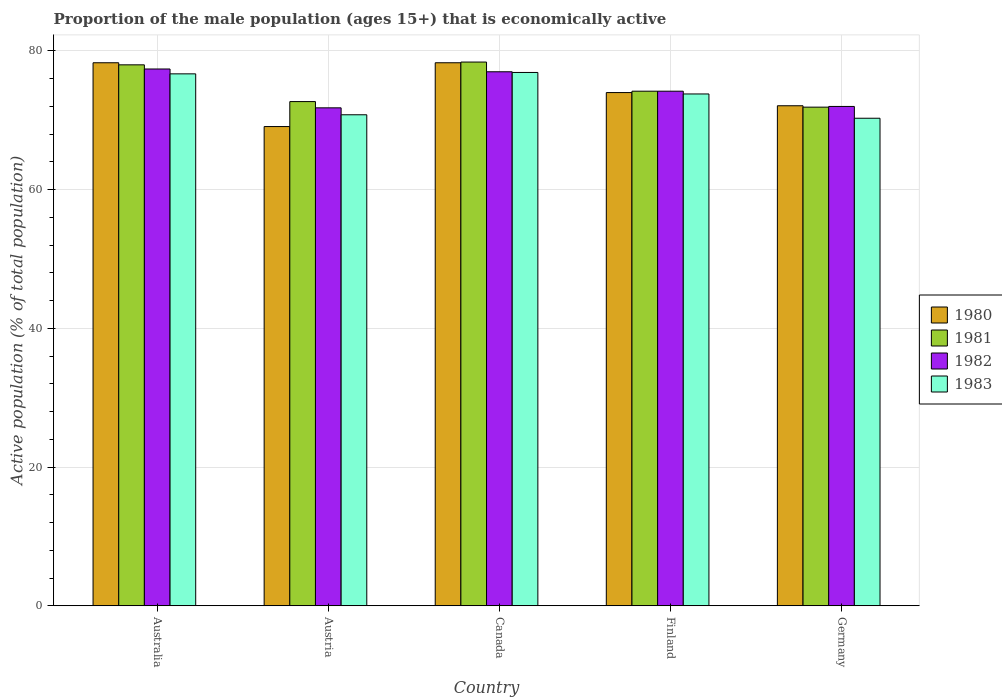Are the number of bars per tick equal to the number of legend labels?
Your response must be concise. Yes. Are the number of bars on each tick of the X-axis equal?
Give a very brief answer. Yes. How many bars are there on the 4th tick from the left?
Offer a very short reply. 4. How many bars are there on the 2nd tick from the right?
Make the answer very short. 4. What is the label of the 1st group of bars from the left?
Provide a succinct answer. Australia. In how many cases, is the number of bars for a given country not equal to the number of legend labels?
Offer a very short reply. 0. What is the proportion of the male population that is economically active in 1980 in Austria?
Ensure brevity in your answer.  69.1. Across all countries, what is the maximum proportion of the male population that is economically active in 1982?
Give a very brief answer. 77.4. Across all countries, what is the minimum proportion of the male population that is economically active in 1982?
Offer a very short reply. 71.8. In which country was the proportion of the male population that is economically active in 1981 minimum?
Give a very brief answer. Germany. What is the total proportion of the male population that is economically active in 1983 in the graph?
Give a very brief answer. 368.5. What is the average proportion of the male population that is economically active in 1983 per country?
Offer a very short reply. 73.7. What is the difference between the proportion of the male population that is economically active of/in 1983 and proportion of the male population that is economically active of/in 1982 in Finland?
Give a very brief answer. -0.4. In how many countries, is the proportion of the male population that is economically active in 1981 greater than 60 %?
Your answer should be very brief. 5. What is the ratio of the proportion of the male population that is economically active in 1983 in Canada to that in Finland?
Your answer should be very brief. 1.04. Is the proportion of the male population that is economically active in 1983 in Canada less than that in Germany?
Keep it short and to the point. No. Is the difference between the proportion of the male population that is economically active in 1983 in Austria and Germany greater than the difference between the proportion of the male population that is economically active in 1982 in Austria and Germany?
Your response must be concise. Yes. What is the difference between the highest and the second highest proportion of the male population that is economically active in 1980?
Provide a short and direct response. -4.3. What is the difference between the highest and the lowest proportion of the male population that is economically active in 1983?
Your answer should be very brief. 6.6. Is it the case that in every country, the sum of the proportion of the male population that is economically active in 1981 and proportion of the male population that is economically active in 1982 is greater than the sum of proportion of the male population that is economically active in 1980 and proportion of the male population that is economically active in 1983?
Make the answer very short. Yes. Are all the bars in the graph horizontal?
Provide a succinct answer. No. How many countries are there in the graph?
Your answer should be very brief. 5. What is the difference between two consecutive major ticks on the Y-axis?
Offer a very short reply. 20. Does the graph contain grids?
Your answer should be very brief. Yes. Where does the legend appear in the graph?
Your answer should be very brief. Center right. How many legend labels are there?
Ensure brevity in your answer.  4. How are the legend labels stacked?
Offer a very short reply. Vertical. What is the title of the graph?
Make the answer very short. Proportion of the male population (ages 15+) that is economically active. Does "1967" appear as one of the legend labels in the graph?
Provide a short and direct response. No. What is the label or title of the Y-axis?
Make the answer very short. Active population (% of total population). What is the Active population (% of total population) of 1980 in Australia?
Provide a short and direct response. 78.3. What is the Active population (% of total population) of 1982 in Australia?
Provide a succinct answer. 77.4. What is the Active population (% of total population) of 1983 in Australia?
Give a very brief answer. 76.7. What is the Active population (% of total population) in 1980 in Austria?
Offer a terse response. 69.1. What is the Active population (% of total population) of 1981 in Austria?
Your answer should be compact. 72.7. What is the Active population (% of total population) in 1982 in Austria?
Provide a short and direct response. 71.8. What is the Active population (% of total population) of 1983 in Austria?
Offer a terse response. 70.8. What is the Active population (% of total population) in 1980 in Canada?
Keep it short and to the point. 78.3. What is the Active population (% of total population) of 1981 in Canada?
Make the answer very short. 78.4. What is the Active population (% of total population) of 1983 in Canada?
Provide a succinct answer. 76.9. What is the Active population (% of total population) in 1980 in Finland?
Your answer should be very brief. 74. What is the Active population (% of total population) in 1981 in Finland?
Provide a succinct answer. 74.2. What is the Active population (% of total population) of 1982 in Finland?
Offer a very short reply. 74.2. What is the Active population (% of total population) in 1983 in Finland?
Make the answer very short. 73.8. What is the Active population (% of total population) of 1980 in Germany?
Provide a succinct answer. 72.1. What is the Active population (% of total population) of 1981 in Germany?
Your response must be concise. 71.9. What is the Active population (% of total population) in 1983 in Germany?
Provide a short and direct response. 70.3. Across all countries, what is the maximum Active population (% of total population) in 1980?
Offer a terse response. 78.3. Across all countries, what is the maximum Active population (% of total population) of 1981?
Offer a very short reply. 78.4. Across all countries, what is the maximum Active population (% of total population) of 1982?
Keep it short and to the point. 77.4. Across all countries, what is the maximum Active population (% of total population) of 1983?
Your answer should be very brief. 76.9. Across all countries, what is the minimum Active population (% of total population) of 1980?
Provide a short and direct response. 69.1. Across all countries, what is the minimum Active population (% of total population) of 1981?
Provide a succinct answer. 71.9. Across all countries, what is the minimum Active population (% of total population) of 1982?
Ensure brevity in your answer.  71.8. Across all countries, what is the minimum Active population (% of total population) in 1983?
Give a very brief answer. 70.3. What is the total Active population (% of total population) in 1980 in the graph?
Keep it short and to the point. 371.8. What is the total Active population (% of total population) in 1981 in the graph?
Offer a terse response. 375.2. What is the total Active population (% of total population) in 1982 in the graph?
Ensure brevity in your answer.  372.4. What is the total Active population (% of total population) in 1983 in the graph?
Provide a succinct answer. 368.5. What is the difference between the Active population (% of total population) of 1980 in Australia and that in Austria?
Provide a succinct answer. 9.2. What is the difference between the Active population (% of total population) in 1981 in Australia and that in Austria?
Provide a succinct answer. 5.3. What is the difference between the Active population (% of total population) in 1982 in Australia and that in Austria?
Keep it short and to the point. 5.6. What is the difference between the Active population (% of total population) of 1983 in Australia and that in Austria?
Your response must be concise. 5.9. What is the difference between the Active population (% of total population) of 1980 in Australia and that in Canada?
Your answer should be compact. 0. What is the difference between the Active population (% of total population) of 1982 in Australia and that in Canada?
Provide a succinct answer. 0.4. What is the difference between the Active population (% of total population) of 1980 in Australia and that in Finland?
Your answer should be compact. 4.3. What is the difference between the Active population (% of total population) in 1980 in Australia and that in Germany?
Keep it short and to the point. 6.2. What is the difference between the Active population (% of total population) of 1981 in Australia and that in Germany?
Make the answer very short. 6.1. What is the difference between the Active population (% of total population) of 1981 in Austria and that in Canada?
Provide a succinct answer. -5.7. What is the difference between the Active population (% of total population) in 1982 in Austria and that in Canada?
Provide a short and direct response. -5.2. What is the difference between the Active population (% of total population) of 1983 in Austria and that in Canada?
Keep it short and to the point. -6.1. What is the difference between the Active population (% of total population) in 1980 in Austria and that in Finland?
Your answer should be compact. -4.9. What is the difference between the Active population (% of total population) in 1981 in Austria and that in Finland?
Ensure brevity in your answer.  -1.5. What is the difference between the Active population (% of total population) of 1982 in Canada and that in Finland?
Your response must be concise. 2.8. What is the difference between the Active population (% of total population) of 1983 in Canada and that in Finland?
Your response must be concise. 3.1. What is the difference between the Active population (% of total population) in 1980 in Canada and that in Germany?
Provide a short and direct response. 6.2. What is the difference between the Active population (% of total population) in 1980 in Finland and that in Germany?
Your answer should be very brief. 1.9. What is the difference between the Active population (% of total population) in 1983 in Finland and that in Germany?
Provide a short and direct response. 3.5. What is the difference between the Active population (% of total population) in 1980 in Australia and the Active population (% of total population) in 1983 in Austria?
Your answer should be very brief. 7.5. What is the difference between the Active population (% of total population) of 1981 in Australia and the Active population (% of total population) of 1982 in Austria?
Offer a very short reply. 6.2. What is the difference between the Active population (% of total population) of 1981 in Australia and the Active population (% of total population) of 1983 in Austria?
Your response must be concise. 7.2. What is the difference between the Active population (% of total population) in 1982 in Australia and the Active population (% of total population) in 1983 in Austria?
Ensure brevity in your answer.  6.6. What is the difference between the Active population (% of total population) of 1980 in Australia and the Active population (% of total population) of 1982 in Canada?
Offer a very short reply. 1.3. What is the difference between the Active population (% of total population) of 1980 in Australia and the Active population (% of total population) of 1983 in Canada?
Provide a short and direct response. 1.4. What is the difference between the Active population (% of total population) of 1982 in Australia and the Active population (% of total population) of 1983 in Finland?
Provide a succinct answer. 3.6. What is the difference between the Active population (% of total population) of 1980 in Australia and the Active population (% of total population) of 1981 in Germany?
Ensure brevity in your answer.  6.4. What is the difference between the Active population (% of total population) in 1980 in Australia and the Active population (% of total population) in 1983 in Germany?
Your answer should be very brief. 8. What is the difference between the Active population (% of total population) of 1980 in Austria and the Active population (% of total population) of 1981 in Canada?
Give a very brief answer. -9.3. What is the difference between the Active population (% of total population) in 1980 in Austria and the Active population (% of total population) in 1983 in Canada?
Your answer should be very brief. -7.8. What is the difference between the Active population (% of total population) of 1981 in Austria and the Active population (% of total population) of 1982 in Canada?
Keep it short and to the point. -4.3. What is the difference between the Active population (% of total population) of 1981 in Austria and the Active population (% of total population) of 1983 in Canada?
Your answer should be very brief. -4.2. What is the difference between the Active population (% of total population) of 1980 in Austria and the Active population (% of total population) of 1981 in Finland?
Provide a short and direct response. -5.1. What is the difference between the Active population (% of total population) in 1980 in Austria and the Active population (% of total population) in 1982 in Finland?
Offer a terse response. -5.1. What is the difference between the Active population (% of total population) in 1981 in Austria and the Active population (% of total population) in 1982 in Finland?
Your answer should be compact. -1.5. What is the difference between the Active population (% of total population) of 1981 in Austria and the Active population (% of total population) of 1983 in Finland?
Offer a terse response. -1.1. What is the difference between the Active population (% of total population) of 1982 in Austria and the Active population (% of total population) of 1983 in Finland?
Make the answer very short. -2. What is the difference between the Active population (% of total population) of 1981 in Austria and the Active population (% of total population) of 1982 in Germany?
Provide a short and direct response. 0.7. What is the difference between the Active population (% of total population) of 1981 in Austria and the Active population (% of total population) of 1983 in Germany?
Keep it short and to the point. 2.4. What is the difference between the Active population (% of total population) of 1982 in Austria and the Active population (% of total population) of 1983 in Germany?
Keep it short and to the point. 1.5. What is the difference between the Active population (% of total population) in 1980 in Canada and the Active population (% of total population) in 1983 in Finland?
Ensure brevity in your answer.  4.5. What is the difference between the Active population (% of total population) of 1981 in Canada and the Active population (% of total population) of 1982 in Finland?
Provide a succinct answer. 4.2. What is the difference between the Active population (% of total population) of 1980 in Canada and the Active population (% of total population) of 1982 in Germany?
Offer a very short reply. 6.3. What is the difference between the Active population (% of total population) in 1980 in Canada and the Active population (% of total population) in 1983 in Germany?
Offer a terse response. 8. What is the difference between the Active population (% of total population) in 1981 in Canada and the Active population (% of total population) in 1982 in Germany?
Your answer should be very brief. 6.4. What is the difference between the Active population (% of total population) of 1980 in Finland and the Active population (% of total population) of 1981 in Germany?
Offer a very short reply. 2.1. What is the difference between the Active population (% of total population) in 1980 in Finland and the Active population (% of total population) in 1983 in Germany?
Your answer should be very brief. 3.7. What is the average Active population (% of total population) in 1980 per country?
Keep it short and to the point. 74.36. What is the average Active population (% of total population) in 1981 per country?
Ensure brevity in your answer.  75.04. What is the average Active population (% of total population) of 1982 per country?
Ensure brevity in your answer.  74.48. What is the average Active population (% of total population) in 1983 per country?
Ensure brevity in your answer.  73.7. What is the difference between the Active population (% of total population) in 1980 and Active population (% of total population) in 1982 in Australia?
Provide a succinct answer. 0.9. What is the difference between the Active population (% of total population) of 1980 and Active population (% of total population) of 1983 in Australia?
Offer a terse response. 1.6. What is the difference between the Active population (% of total population) in 1981 and Active population (% of total population) in 1982 in Australia?
Ensure brevity in your answer.  0.6. What is the difference between the Active population (% of total population) of 1981 and Active population (% of total population) of 1983 in Australia?
Your answer should be very brief. 1.3. What is the difference between the Active population (% of total population) in 1982 and Active population (% of total population) in 1983 in Australia?
Make the answer very short. 0.7. What is the difference between the Active population (% of total population) in 1980 and Active population (% of total population) in 1982 in Austria?
Make the answer very short. -2.7. What is the difference between the Active population (% of total population) of 1980 and Active population (% of total population) of 1983 in Austria?
Provide a succinct answer. -1.7. What is the difference between the Active population (% of total population) of 1981 and Active population (% of total population) of 1982 in Austria?
Your answer should be very brief. 0.9. What is the difference between the Active population (% of total population) in 1982 and Active population (% of total population) in 1983 in Austria?
Your answer should be compact. 1. What is the difference between the Active population (% of total population) of 1980 and Active population (% of total population) of 1982 in Canada?
Keep it short and to the point. 1.3. What is the difference between the Active population (% of total population) in 1980 and Active population (% of total population) in 1983 in Canada?
Your response must be concise. 1.4. What is the difference between the Active population (% of total population) of 1981 and Active population (% of total population) of 1983 in Canada?
Make the answer very short. 1.5. What is the difference between the Active population (% of total population) of 1980 and Active population (% of total population) of 1982 in Finland?
Make the answer very short. -0.2. What is the difference between the Active population (% of total population) of 1980 and Active population (% of total population) of 1982 in Germany?
Offer a terse response. 0.1. What is the difference between the Active population (% of total population) of 1981 and Active population (% of total population) of 1982 in Germany?
Ensure brevity in your answer.  -0.1. What is the difference between the Active population (% of total population) in 1982 and Active population (% of total population) in 1983 in Germany?
Make the answer very short. 1.7. What is the ratio of the Active population (% of total population) in 1980 in Australia to that in Austria?
Provide a short and direct response. 1.13. What is the ratio of the Active population (% of total population) of 1981 in Australia to that in Austria?
Offer a terse response. 1.07. What is the ratio of the Active population (% of total population) of 1982 in Australia to that in Austria?
Your answer should be very brief. 1.08. What is the ratio of the Active population (% of total population) of 1980 in Australia to that in Canada?
Your answer should be very brief. 1. What is the ratio of the Active population (% of total population) in 1981 in Australia to that in Canada?
Ensure brevity in your answer.  0.99. What is the ratio of the Active population (% of total population) of 1980 in Australia to that in Finland?
Provide a succinct answer. 1.06. What is the ratio of the Active population (% of total population) of 1981 in Australia to that in Finland?
Your answer should be compact. 1.05. What is the ratio of the Active population (% of total population) in 1982 in Australia to that in Finland?
Keep it short and to the point. 1.04. What is the ratio of the Active population (% of total population) in 1983 in Australia to that in Finland?
Your answer should be very brief. 1.04. What is the ratio of the Active population (% of total population) of 1980 in Australia to that in Germany?
Keep it short and to the point. 1.09. What is the ratio of the Active population (% of total population) of 1981 in Australia to that in Germany?
Your answer should be very brief. 1.08. What is the ratio of the Active population (% of total population) in 1982 in Australia to that in Germany?
Give a very brief answer. 1.07. What is the ratio of the Active population (% of total population) in 1983 in Australia to that in Germany?
Offer a terse response. 1.09. What is the ratio of the Active population (% of total population) of 1980 in Austria to that in Canada?
Provide a succinct answer. 0.88. What is the ratio of the Active population (% of total population) in 1981 in Austria to that in Canada?
Ensure brevity in your answer.  0.93. What is the ratio of the Active population (% of total population) in 1982 in Austria to that in Canada?
Ensure brevity in your answer.  0.93. What is the ratio of the Active population (% of total population) in 1983 in Austria to that in Canada?
Your answer should be compact. 0.92. What is the ratio of the Active population (% of total population) of 1980 in Austria to that in Finland?
Offer a very short reply. 0.93. What is the ratio of the Active population (% of total population) in 1981 in Austria to that in Finland?
Offer a terse response. 0.98. What is the ratio of the Active population (% of total population) in 1982 in Austria to that in Finland?
Your response must be concise. 0.97. What is the ratio of the Active population (% of total population) of 1983 in Austria to that in Finland?
Your answer should be very brief. 0.96. What is the ratio of the Active population (% of total population) in 1980 in Austria to that in Germany?
Provide a succinct answer. 0.96. What is the ratio of the Active population (% of total population) in 1981 in Austria to that in Germany?
Make the answer very short. 1.01. What is the ratio of the Active population (% of total population) in 1982 in Austria to that in Germany?
Your answer should be very brief. 1. What is the ratio of the Active population (% of total population) of 1983 in Austria to that in Germany?
Keep it short and to the point. 1.01. What is the ratio of the Active population (% of total population) in 1980 in Canada to that in Finland?
Provide a short and direct response. 1.06. What is the ratio of the Active population (% of total population) in 1981 in Canada to that in Finland?
Provide a short and direct response. 1.06. What is the ratio of the Active population (% of total population) of 1982 in Canada to that in Finland?
Provide a short and direct response. 1.04. What is the ratio of the Active population (% of total population) in 1983 in Canada to that in Finland?
Ensure brevity in your answer.  1.04. What is the ratio of the Active population (% of total population) of 1980 in Canada to that in Germany?
Provide a succinct answer. 1.09. What is the ratio of the Active population (% of total population) of 1981 in Canada to that in Germany?
Ensure brevity in your answer.  1.09. What is the ratio of the Active population (% of total population) of 1982 in Canada to that in Germany?
Make the answer very short. 1.07. What is the ratio of the Active population (% of total population) of 1983 in Canada to that in Germany?
Provide a short and direct response. 1.09. What is the ratio of the Active population (% of total population) of 1980 in Finland to that in Germany?
Keep it short and to the point. 1.03. What is the ratio of the Active population (% of total population) in 1981 in Finland to that in Germany?
Your answer should be compact. 1.03. What is the ratio of the Active population (% of total population) of 1982 in Finland to that in Germany?
Offer a terse response. 1.03. What is the ratio of the Active population (% of total population) in 1983 in Finland to that in Germany?
Offer a terse response. 1.05. What is the difference between the highest and the second highest Active population (% of total population) of 1983?
Ensure brevity in your answer.  0.2. What is the difference between the highest and the lowest Active population (% of total population) in 1982?
Provide a succinct answer. 5.6. 